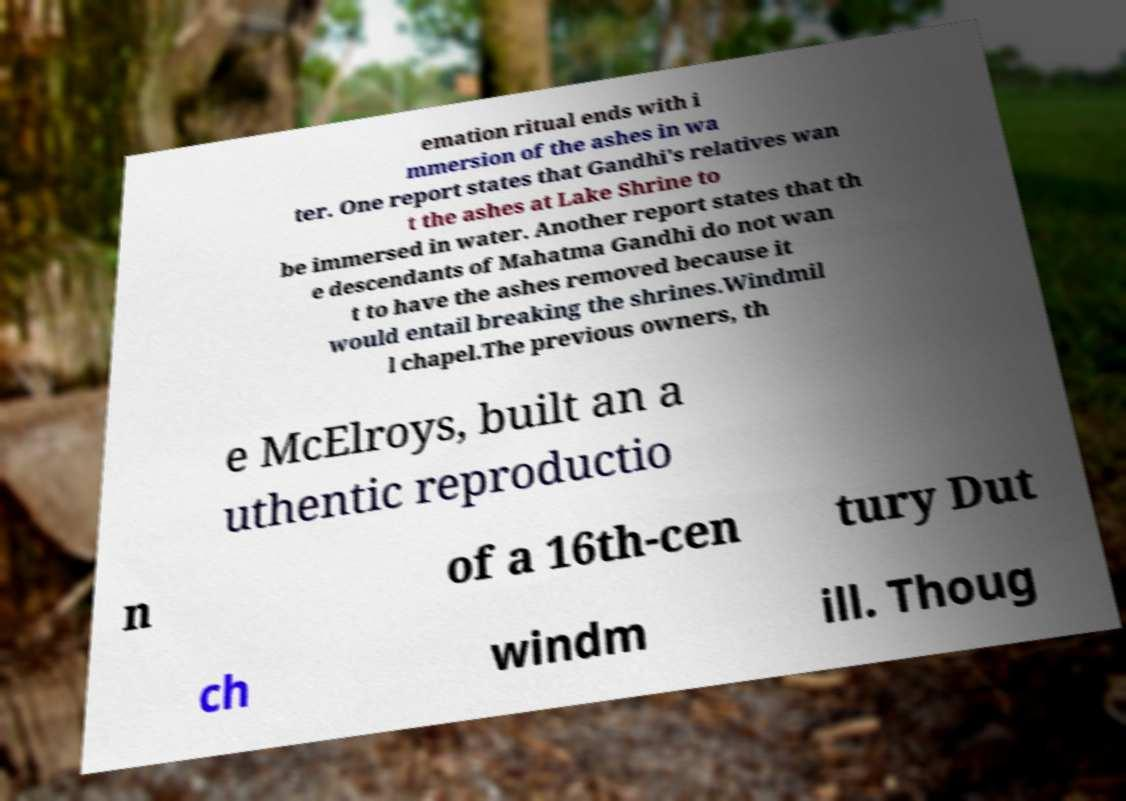Could you extract and type out the text from this image? emation ritual ends with i mmersion of the ashes in wa ter. One report states that Gandhi's relatives wan t the ashes at Lake Shrine to be immersed in water. Another report states that th e descendants of Mahatma Gandhi do not wan t to have the ashes removed because it would entail breaking the shrines.Windmil l chapel.The previous owners, th e McElroys, built an a uthentic reproductio n of a 16th-cen tury Dut ch windm ill. Thoug 